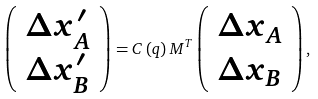Convert formula to latex. <formula><loc_0><loc_0><loc_500><loc_500>\left ( \begin{array} { c } \Delta x _ { A } ^ { \prime } \\ \Delta x _ { B } ^ { \prime } \end{array} \right ) = C \left ( q \right ) M ^ { T } \left ( \begin{array} { c } \Delta x _ { A } \\ \Delta x _ { B } \end{array} \right ) ,</formula> 